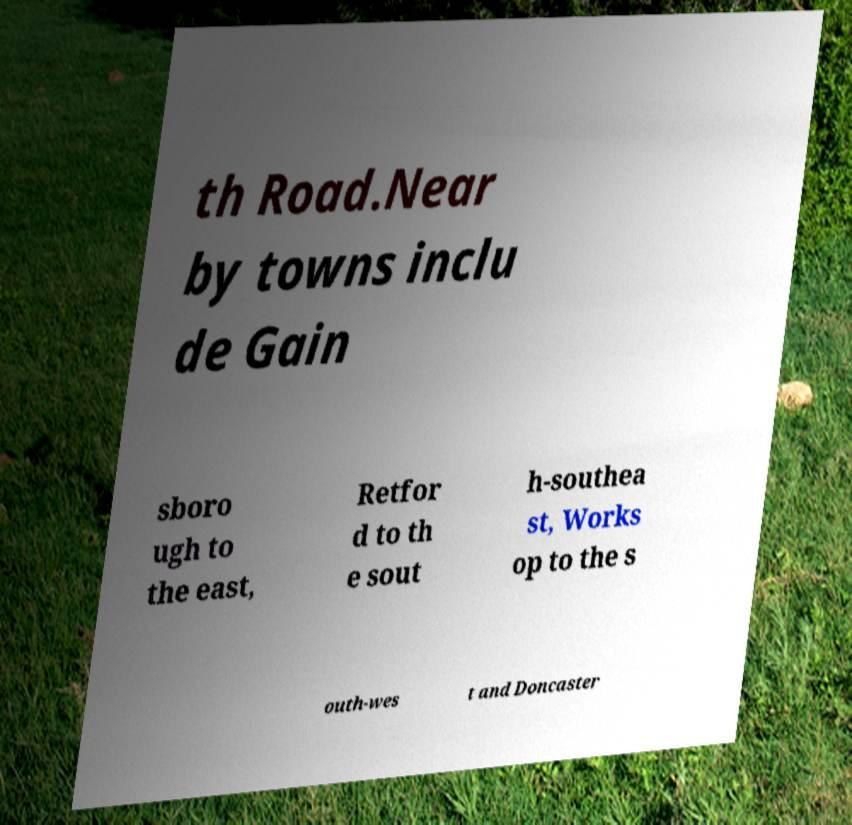I need the written content from this picture converted into text. Can you do that? th Road.Near by towns inclu de Gain sboro ugh to the east, Retfor d to th e sout h-southea st, Works op to the s outh-wes t and Doncaster 